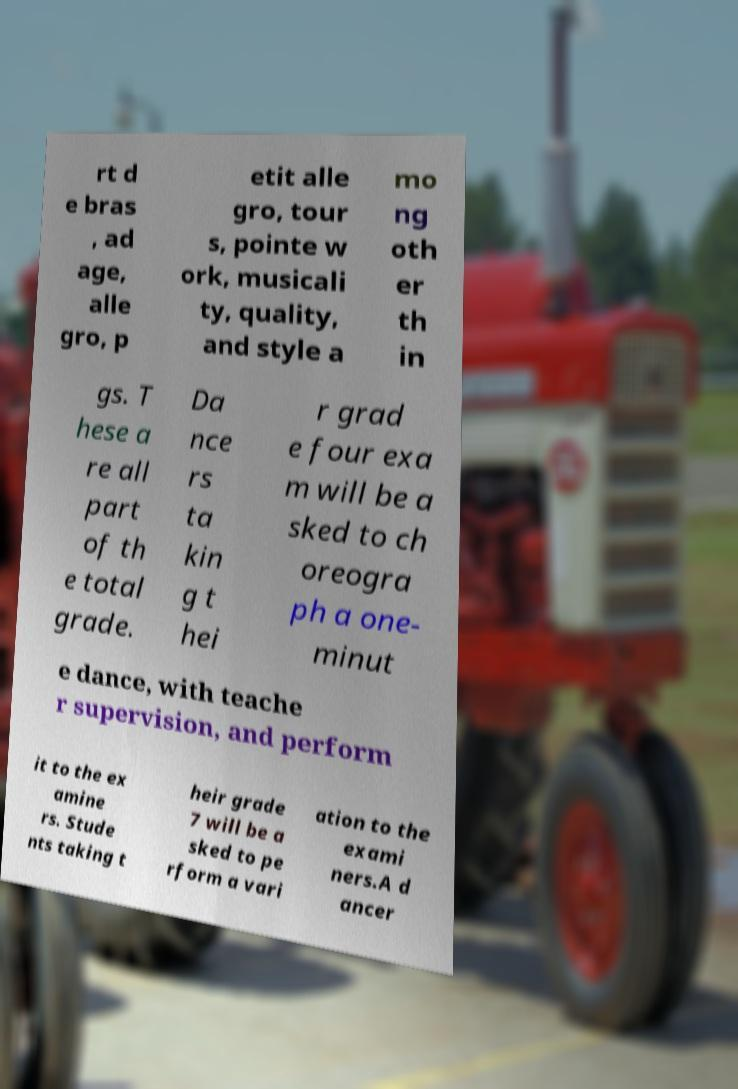Could you assist in decoding the text presented in this image and type it out clearly? rt d e bras , ad age, alle gro, p etit alle gro, tour s, pointe w ork, musicali ty, quality, and style a mo ng oth er th in gs. T hese a re all part of th e total grade. Da nce rs ta kin g t hei r grad e four exa m will be a sked to ch oreogra ph a one- minut e dance, with teache r supervision, and perform it to the ex amine rs. Stude nts taking t heir grade 7 will be a sked to pe rform a vari ation to the exami ners.A d ancer 